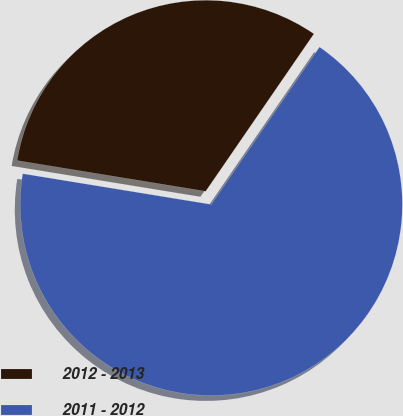<chart> <loc_0><loc_0><loc_500><loc_500><pie_chart><fcel>2012 - 2013<fcel>2011 - 2012<nl><fcel>32.01%<fcel>67.99%<nl></chart> 